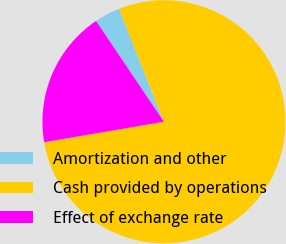<chart> <loc_0><loc_0><loc_500><loc_500><pie_chart><fcel>Amortization and other<fcel>Cash provided by operations<fcel>Effect of exchange rate<nl><fcel>3.42%<fcel>78.31%<fcel>18.26%<nl></chart> 